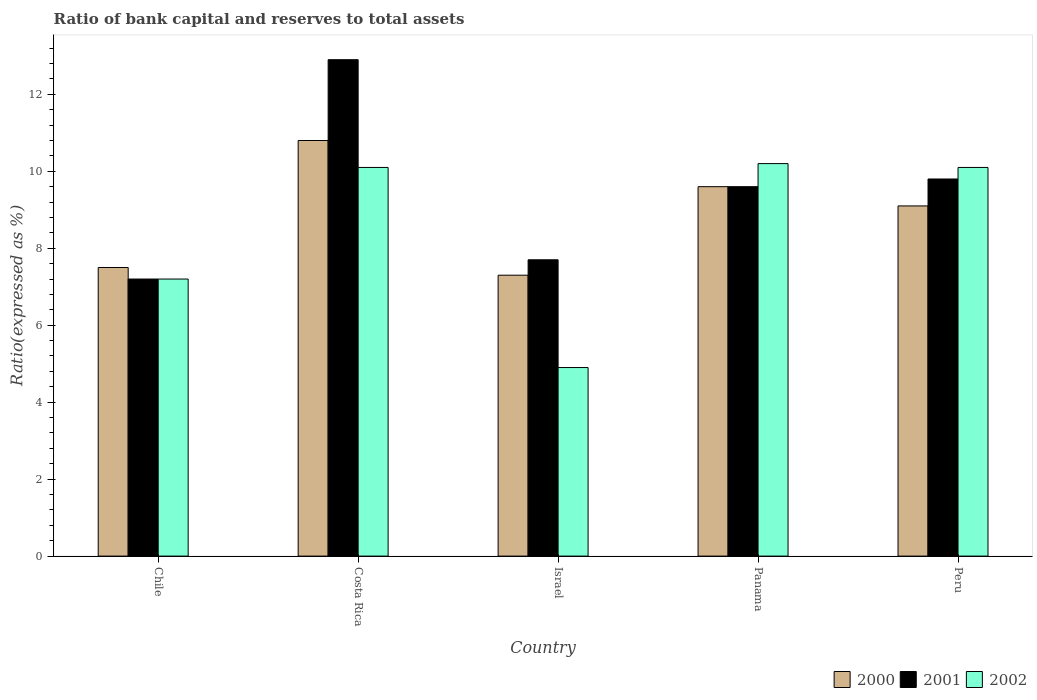How many different coloured bars are there?
Your answer should be very brief. 3. Are the number of bars per tick equal to the number of legend labels?
Offer a very short reply. Yes. How many bars are there on the 2nd tick from the left?
Make the answer very short. 3. How many bars are there on the 5th tick from the right?
Provide a succinct answer. 3. What is the label of the 3rd group of bars from the left?
Your answer should be compact. Israel. What is the ratio of bank capital and reserves to total assets in 2001 in Israel?
Offer a terse response. 7.7. Across all countries, what is the maximum ratio of bank capital and reserves to total assets in 2002?
Ensure brevity in your answer.  10.2. Across all countries, what is the minimum ratio of bank capital and reserves to total assets in 2002?
Offer a terse response. 4.9. In which country was the ratio of bank capital and reserves to total assets in 2001 maximum?
Make the answer very short. Costa Rica. In which country was the ratio of bank capital and reserves to total assets in 2002 minimum?
Your answer should be compact. Israel. What is the total ratio of bank capital and reserves to total assets in 2002 in the graph?
Provide a short and direct response. 42.5. What is the difference between the ratio of bank capital and reserves to total assets in 2002 in Chile and that in Costa Rica?
Offer a very short reply. -2.9. What is the difference between the ratio of bank capital and reserves to total assets in 2001 in Panama and the ratio of bank capital and reserves to total assets in 2002 in Chile?
Your answer should be very brief. 2.4. What is the average ratio of bank capital and reserves to total assets in 2002 per country?
Make the answer very short. 8.5. What is the difference between the ratio of bank capital and reserves to total assets of/in 2002 and ratio of bank capital and reserves to total assets of/in 2000 in Chile?
Keep it short and to the point. -0.3. What is the ratio of the ratio of bank capital and reserves to total assets in 2002 in Israel to that in Peru?
Your response must be concise. 0.49. Is the ratio of bank capital and reserves to total assets in 2002 in Costa Rica less than that in Israel?
Your answer should be compact. No. What is the difference between the highest and the second highest ratio of bank capital and reserves to total assets in 2001?
Keep it short and to the point. -3.1. What is the difference between the highest and the lowest ratio of bank capital and reserves to total assets in 2000?
Your answer should be compact. 3.5. What does the 3rd bar from the left in Israel represents?
Your answer should be very brief. 2002. What does the 2nd bar from the right in Panama represents?
Ensure brevity in your answer.  2001. How many bars are there?
Your response must be concise. 15. How many countries are there in the graph?
Give a very brief answer. 5. Are the values on the major ticks of Y-axis written in scientific E-notation?
Your answer should be compact. No. Does the graph contain any zero values?
Make the answer very short. No. Does the graph contain grids?
Give a very brief answer. No. How many legend labels are there?
Your response must be concise. 3. What is the title of the graph?
Offer a terse response. Ratio of bank capital and reserves to total assets. What is the label or title of the X-axis?
Offer a terse response. Country. What is the label or title of the Y-axis?
Make the answer very short. Ratio(expressed as %). What is the Ratio(expressed as %) of 2000 in Chile?
Your response must be concise. 7.5. What is the Ratio(expressed as %) of 2001 in Costa Rica?
Your answer should be compact. 12.9. What is the Ratio(expressed as %) of 2002 in Costa Rica?
Provide a succinct answer. 10.1. What is the Ratio(expressed as %) in 2000 in Israel?
Offer a terse response. 7.3. What is the Ratio(expressed as %) in 2002 in Israel?
Your answer should be compact. 4.9. What is the Ratio(expressed as %) in 2000 in Panama?
Your response must be concise. 9.6. What is the Ratio(expressed as %) in 2002 in Panama?
Give a very brief answer. 10.2. What is the Ratio(expressed as %) in 2000 in Peru?
Your answer should be very brief. 9.1. What is the Ratio(expressed as %) of 2001 in Peru?
Make the answer very short. 9.8. Across all countries, what is the maximum Ratio(expressed as %) of 2002?
Your answer should be compact. 10.2. Across all countries, what is the minimum Ratio(expressed as %) of 2000?
Offer a terse response. 7.3. Across all countries, what is the minimum Ratio(expressed as %) in 2001?
Your answer should be compact. 7.2. Across all countries, what is the minimum Ratio(expressed as %) of 2002?
Your answer should be very brief. 4.9. What is the total Ratio(expressed as %) of 2000 in the graph?
Your response must be concise. 44.3. What is the total Ratio(expressed as %) of 2001 in the graph?
Your answer should be very brief. 47.2. What is the total Ratio(expressed as %) in 2002 in the graph?
Ensure brevity in your answer.  42.5. What is the difference between the Ratio(expressed as %) in 2002 in Chile and that in Costa Rica?
Offer a terse response. -2.9. What is the difference between the Ratio(expressed as %) of 2000 in Chile and that in Israel?
Your answer should be compact. 0.2. What is the difference between the Ratio(expressed as %) of 2002 in Chile and that in Israel?
Keep it short and to the point. 2.3. What is the difference between the Ratio(expressed as %) in 2000 in Chile and that in Panama?
Provide a succinct answer. -2.1. What is the difference between the Ratio(expressed as %) in 2000 in Chile and that in Peru?
Your response must be concise. -1.6. What is the difference between the Ratio(expressed as %) in 2000 in Costa Rica and that in Israel?
Offer a very short reply. 3.5. What is the difference between the Ratio(expressed as %) in 2002 in Costa Rica and that in Israel?
Make the answer very short. 5.2. What is the difference between the Ratio(expressed as %) of 2000 in Costa Rica and that in Peru?
Provide a short and direct response. 1.7. What is the difference between the Ratio(expressed as %) of 2001 in Costa Rica and that in Peru?
Provide a succinct answer. 3.1. What is the difference between the Ratio(expressed as %) of 2002 in Costa Rica and that in Peru?
Provide a succinct answer. 0. What is the difference between the Ratio(expressed as %) in 2000 in Israel and that in Panama?
Provide a succinct answer. -2.3. What is the difference between the Ratio(expressed as %) of 2001 in Israel and that in Panama?
Offer a very short reply. -1.9. What is the difference between the Ratio(expressed as %) in 2002 in Israel and that in Panama?
Offer a very short reply. -5.3. What is the difference between the Ratio(expressed as %) of 2002 in Israel and that in Peru?
Ensure brevity in your answer.  -5.2. What is the difference between the Ratio(expressed as %) of 2000 in Panama and that in Peru?
Provide a short and direct response. 0.5. What is the difference between the Ratio(expressed as %) of 2001 in Panama and that in Peru?
Offer a very short reply. -0.2. What is the difference between the Ratio(expressed as %) of 2000 in Chile and the Ratio(expressed as %) of 2001 in Costa Rica?
Make the answer very short. -5.4. What is the difference between the Ratio(expressed as %) in 2000 in Chile and the Ratio(expressed as %) in 2002 in Costa Rica?
Make the answer very short. -2.6. What is the difference between the Ratio(expressed as %) in 2001 in Chile and the Ratio(expressed as %) in 2002 in Costa Rica?
Give a very brief answer. -2.9. What is the difference between the Ratio(expressed as %) of 2000 in Chile and the Ratio(expressed as %) of 2001 in Israel?
Keep it short and to the point. -0.2. What is the difference between the Ratio(expressed as %) of 2000 in Chile and the Ratio(expressed as %) of 2002 in Israel?
Offer a terse response. 2.6. What is the difference between the Ratio(expressed as %) of 2000 in Chile and the Ratio(expressed as %) of 2001 in Panama?
Keep it short and to the point. -2.1. What is the difference between the Ratio(expressed as %) of 2000 in Chile and the Ratio(expressed as %) of 2002 in Panama?
Offer a terse response. -2.7. What is the difference between the Ratio(expressed as %) of 2001 in Chile and the Ratio(expressed as %) of 2002 in Panama?
Provide a short and direct response. -3. What is the difference between the Ratio(expressed as %) of 2000 in Chile and the Ratio(expressed as %) of 2002 in Peru?
Your response must be concise. -2.6. What is the difference between the Ratio(expressed as %) of 2001 in Chile and the Ratio(expressed as %) of 2002 in Peru?
Your response must be concise. -2.9. What is the difference between the Ratio(expressed as %) in 2000 in Costa Rica and the Ratio(expressed as %) in 2001 in Israel?
Provide a short and direct response. 3.1. What is the difference between the Ratio(expressed as %) in 2000 in Costa Rica and the Ratio(expressed as %) in 2002 in Israel?
Ensure brevity in your answer.  5.9. What is the difference between the Ratio(expressed as %) in 2000 in Costa Rica and the Ratio(expressed as %) in 2001 in Panama?
Give a very brief answer. 1.2. What is the difference between the Ratio(expressed as %) of 2001 in Costa Rica and the Ratio(expressed as %) of 2002 in Panama?
Offer a very short reply. 2.7. What is the difference between the Ratio(expressed as %) of 2000 in Costa Rica and the Ratio(expressed as %) of 2001 in Peru?
Make the answer very short. 1. What is the difference between the Ratio(expressed as %) of 2000 in Israel and the Ratio(expressed as %) of 2001 in Panama?
Offer a very short reply. -2.3. What is the difference between the Ratio(expressed as %) of 2001 in Israel and the Ratio(expressed as %) of 2002 in Panama?
Your answer should be very brief. -2.5. What is the difference between the Ratio(expressed as %) in 2001 in Israel and the Ratio(expressed as %) in 2002 in Peru?
Provide a short and direct response. -2.4. What is the difference between the Ratio(expressed as %) of 2000 in Panama and the Ratio(expressed as %) of 2001 in Peru?
Offer a terse response. -0.2. What is the difference between the Ratio(expressed as %) of 2001 in Panama and the Ratio(expressed as %) of 2002 in Peru?
Your answer should be compact. -0.5. What is the average Ratio(expressed as %) in 2000 per country?
Keep it short and to the point. 8.86. What is the average Ratio(expressed as %) in 2001 per country?
Provide a short and direct response. 9.44. What is the difference between the Ratio(expressed as %) in 2000 and Ratio(expressed as %) in 2001 in Chile?
Offer a very short reply. 0.3. What is the difference between the Ratio(expressed as %) in 2000 and Ratio(expressed as %) in 2002 in Costa Rica?
Provide a succinct answer. 0.7. What is the difference between the Ratio(expressed as %) in 2001 and Ratio(expressed as %) in 2002 in Costa Rica?
Your response must be concise. 2.8. What is the difference between the Ratio(expressed as %) of 2000 and Ratio(expressed as %) of 2001 in Israel?
Make the answer very short. -0.4. What is the difference between the Ratio(expressed as %) of 2000 and Ratio(expressed as %) of 2002 in Israel?
Give a very brief answer. 2.4. What is the difference between the Ratio(expressed as %) in 2001 and Ratio(expressed as %) in 2002 in Israel?
Offer a terse response. 2.8. What is the difference between the Ratio(expressed as %) of 2000 and Ratio(expressed as %) of 2001 in Panama?
Provide a succinct answer. 0. What is the difference between the Ratio(expressed as %) of 2001 and Ratio(expressed as %) of 2002 in Panama?
Provide a succinct answer. -0.6. What is the difference between the Ratio(expressed as %) in 2000 and Ratio(expressed as %) in 2001 in Peru?
Keep it short and to the point. -0.7. What is the difference between the Ratio(expressed as %) of 2000 and Ratio(expressed as %) of 2002 in Peru?
Your answer should be very brief. -1. What is the ratio of the Ratio(expressed as %) in 2000 in Chile to that in Costa Rica?
Provide a succinct answer. 0.69. What is the ratio of the Ratio(expressed as %) in 2001 in Chile to that in Costa Rica?
Keep it short and to the point. 0.56. What is the ratio of the Ratio(expressed as %) of 2002 in Chile to that in Costa Rica?
Offer a very short reply. 0.71. What is the ratio of the Ratio(expressed as %) in 2000 in Chile to that in Israel?
Keep it short and to the point. 1.03. What is the ratio of the Ratio(expressed as %) in 2001 in Chile to that in Israel?
Keep it short and to the point. 0.94. What is the ratio of the Ratio(expressed as %) in 2002 in Chile to that in Israel?
Provide a succinct answer. 1.47. What is the ratio of the Ratio(expressed as %) in 2000 in Chile to that in Panama?
Offer a terse response. 0.78. What is the ratio of the Ratio(expressed as %) of 2001 in Chile to that in Panama?
Offer a very short reply. 0.75. What is the ratio of the Ratio(expressed as %) of 2002 in Chile to that in Panama?
Make the answer very short. 0.71. What is the ratio of the Ratio(expressed as %) of 2000 in Chile to that in Peru?
Offer a very short reply. 0.82. What is the ratio of the Ratio(expressed as %) in 2001 in Chile to that in Peru?
Offer a terse response. 0.73. What is the ratio of the Ratio(expressed as %) of 2002 in Chile to that in Peru?
Offer a terse response. 0.71. What is the ratio of the Ratio(expressed as %) of 2000 in Costa Rica to that in Israel?
Make the answer very short. 1.48. What is the ratio of the Ratio(expressed as %) in 2001 in Costa Rica to that in Israel?
Ensure brevity in your answer.  1.68. What is the ratio of the Ratio(expressed as %) of 2002 in Costa Rica to that in Israel?
Offer a terse response. 2.06. What is the ratio of the Ratio(expressed as %) in 2000 in Costa Rica to that in Panama?
Your answer should be very brief. 1.12. What is the ratio of the Ratio(expressed as %) in 2001 in Costa Rica to that in Panama?
Offer a very short reply. 1.34. What is the ratio of the Ratio(expressed as %) of 2002 in Costa Rica to that in Panama?
Your answer should be compact. 0.99. What is the ratio of the Ratio(expressed as %) of 2000 in Costa Rica to that in Peru?
Your response must be concise. 1.19. What is the ratio of the Ratio(expressed as %) of 2001 in Costa Rica to that in Peru?
Provide a succinct answer. 1.32. What is the ratio of the Ratio(expressed as %) of 2000 in Israel to that in Panama?
Provide a succinct answer. 0.76. What is the ratio of the Ratio(expressed as %) of 2001 in Israel to that in Panama?
Provide a succinct answer. 0.8. What is the ratio of the Ratio(expressed as %) in 2002 in Israel to that in Panama?
Your answer should be compact. 0.48. What is the ratio of the Ratio(expressed as %) in 2000 in Israel to that in Peru?
Offer a terse response. 0.8. What is the ratio of the Ratio(expressed as %) in 2001 in Israel to that in Peru?
Provide a short and direct response. 0.79. What is the ratio of the Ratio(expressed as %) in 2002 in Israel to that in Peru?
Your answer should be very brief. 0.49. What is the ratio of the Ratio(expressed as %) of 2000 in Panama to that in Peru?
Provide a succinct answer. 1.05. What is the ratio of the Ratio(expressed as %) of 2001 in Panama to that in Peru?
Keep it short and to the point. 0.98. What is the ratio of the Ratio(expressed as %) of 2002 in Panama to that in Peru?
Make the answer very short. 1.01. What is the difference between the highest and the second highest Ratio(expressed as %) in 2000?
Ensure brevity in your answer.  1.2. What is the difference between the highest and the second highest Ratio(expressed as %) of 2001?
Your response must be concise. 3.1. What is the difference between the highest and the lowest Ratio(expressed as %) of 2000?
Offer a very short reply. 3.5. What is the difference between the highest and the lowest Ratio(expressed as %) in 2002?
Your response must be concise. 5.3. 